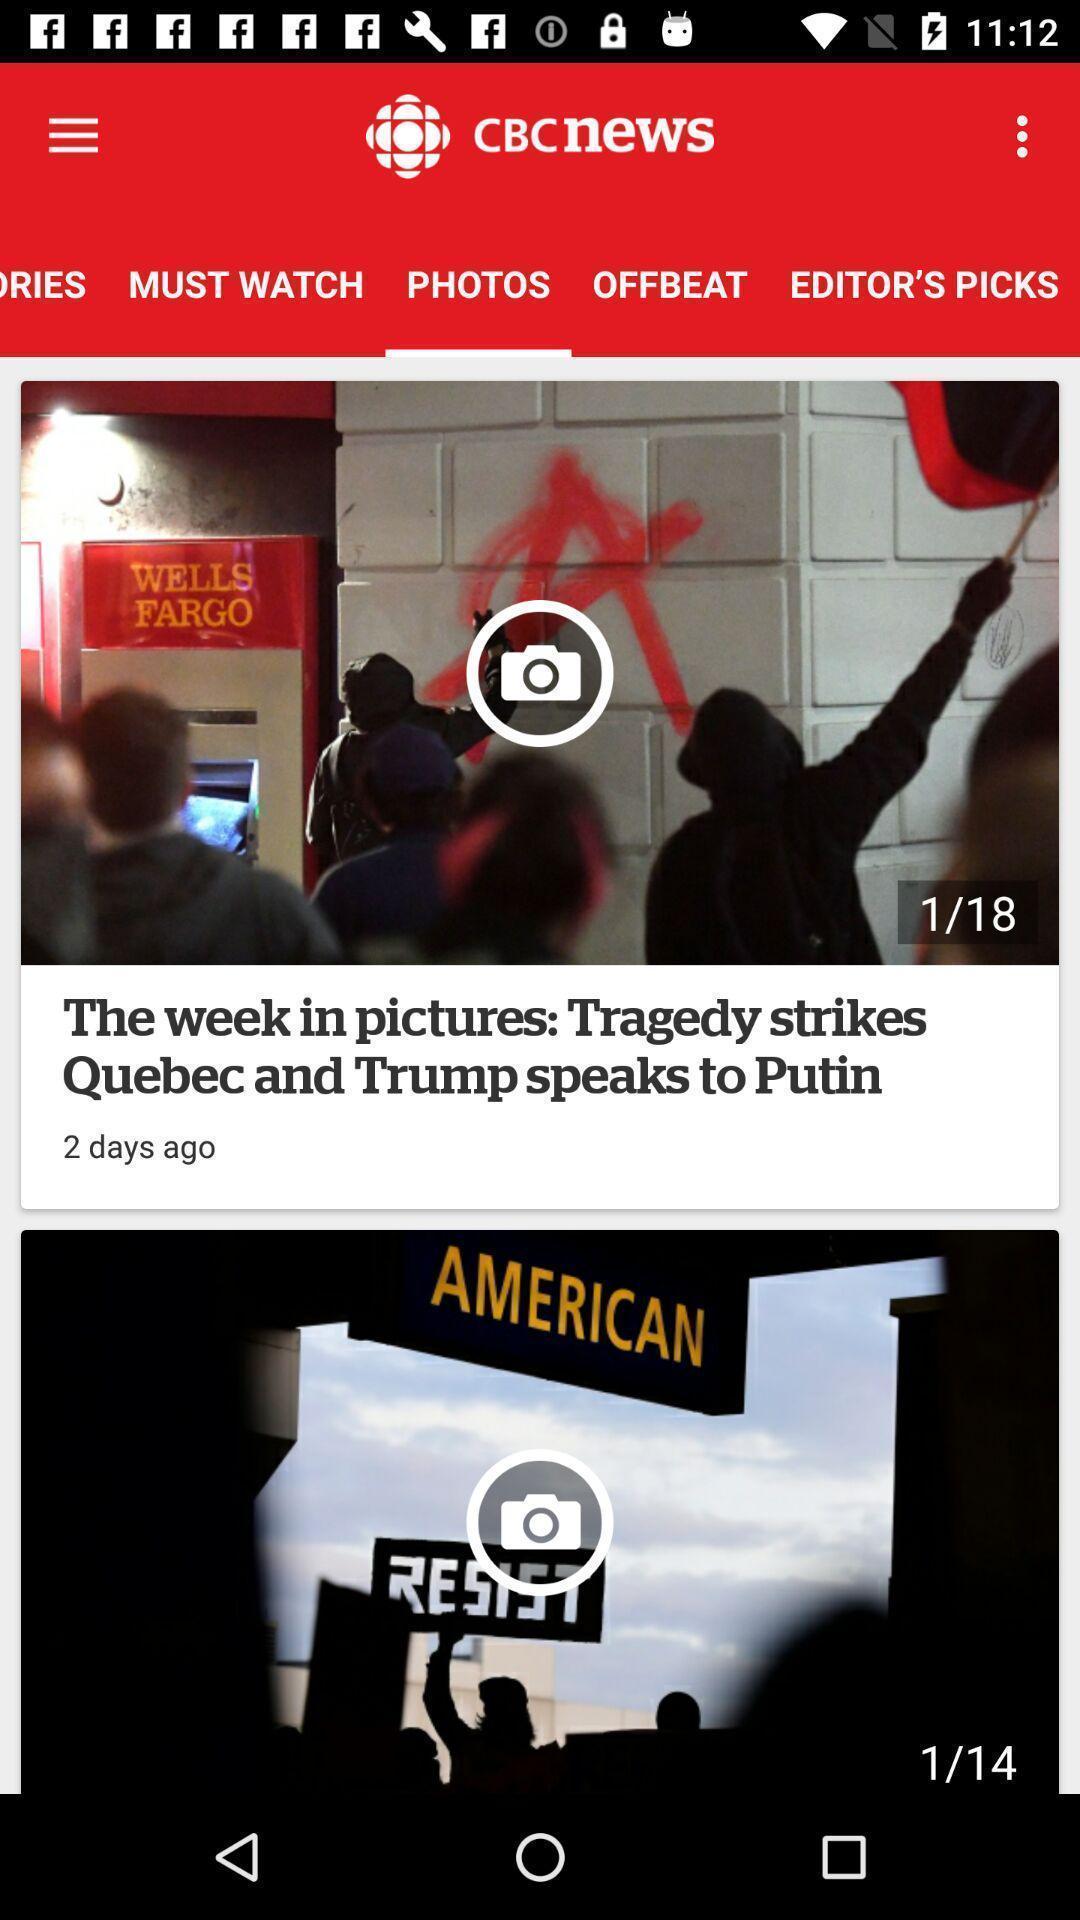What is the overall content of this screenshot? Screen shows about live news app. 